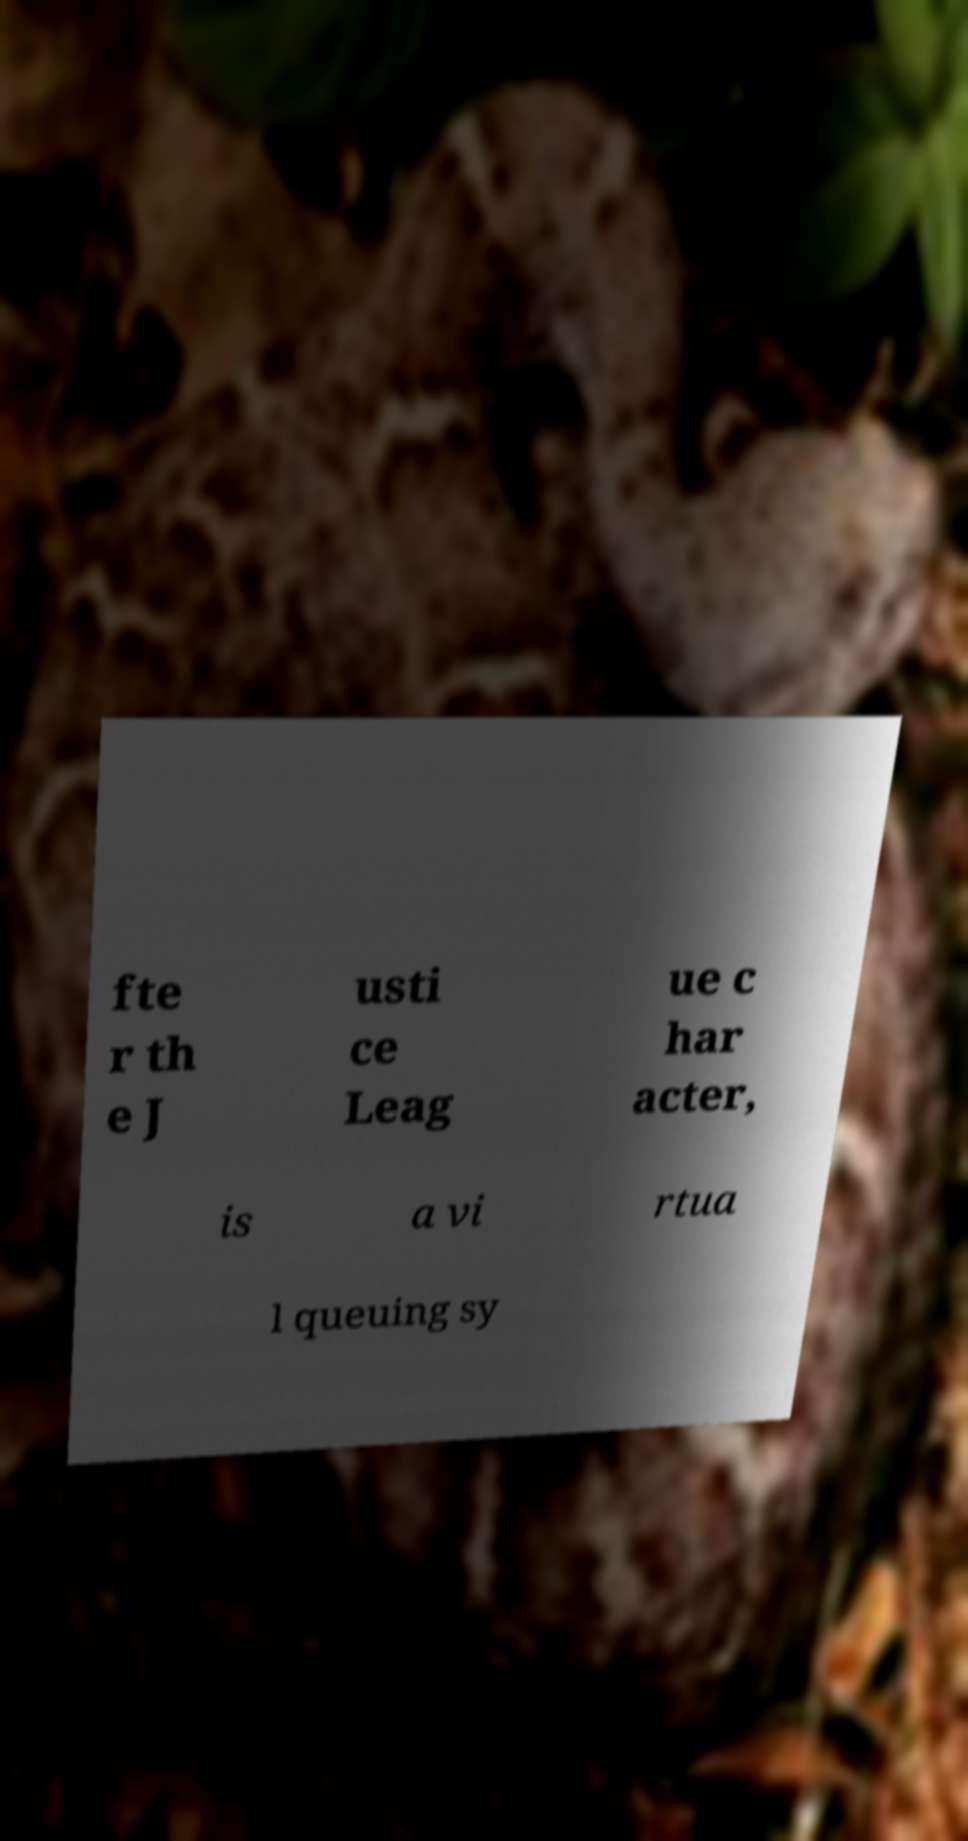Please read and relay the text visible in this image. What does it say? fte r th e J usti ce Leag ue c har acter, is a vi rtua l queuing sy 